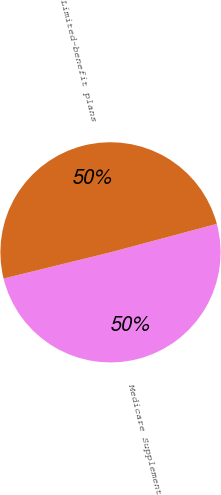Convert chart. <chart><loc_0><loc_0><loc_500><loc_500><pie_chart><fcel>Medicare Supplement<fcel>Limited-benefit plans<nl><fcel>50.34%<fcel>49.66%<nl></chart> 